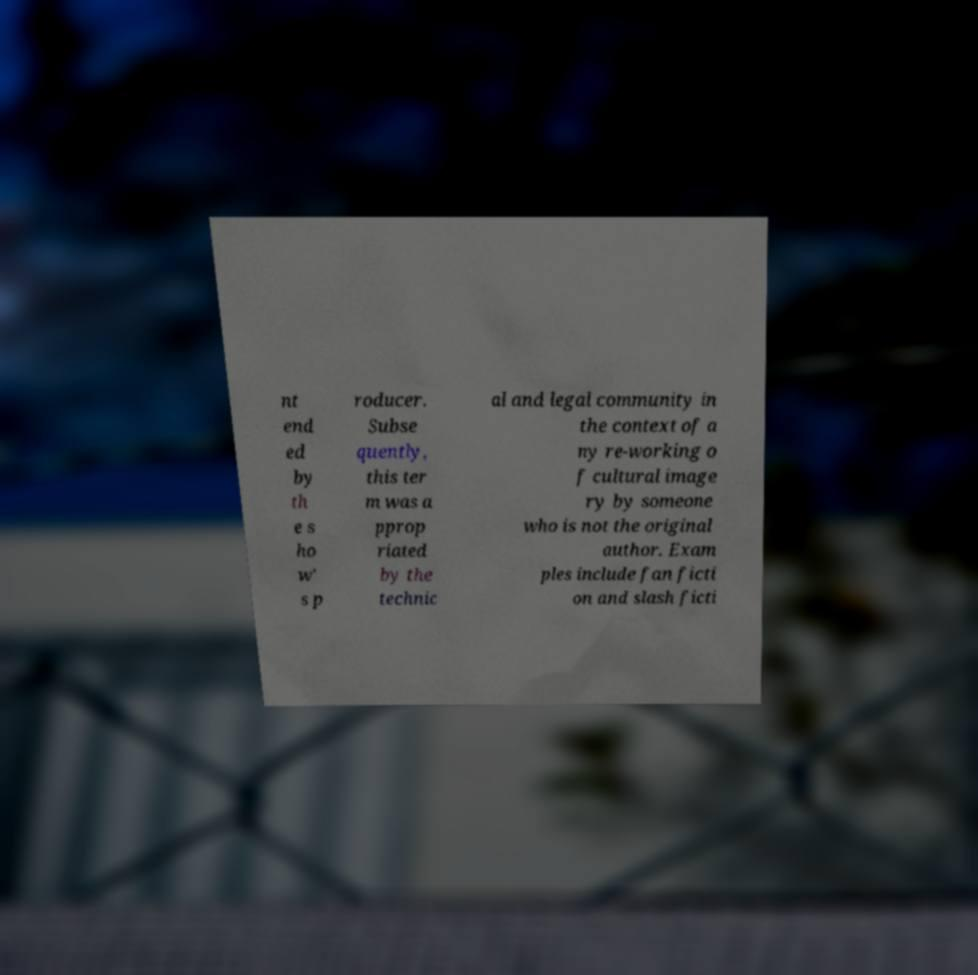Please identify and transcribe the text found in this image. nt end ed by th e s ho w' s p roducer. Subse quently, this ter m was a pprop riated by the technic al and legal community in the context of a ny re-working o f cultural image ry by someone who is not the original author. Exam ples include fan ficti on and slash ficti 